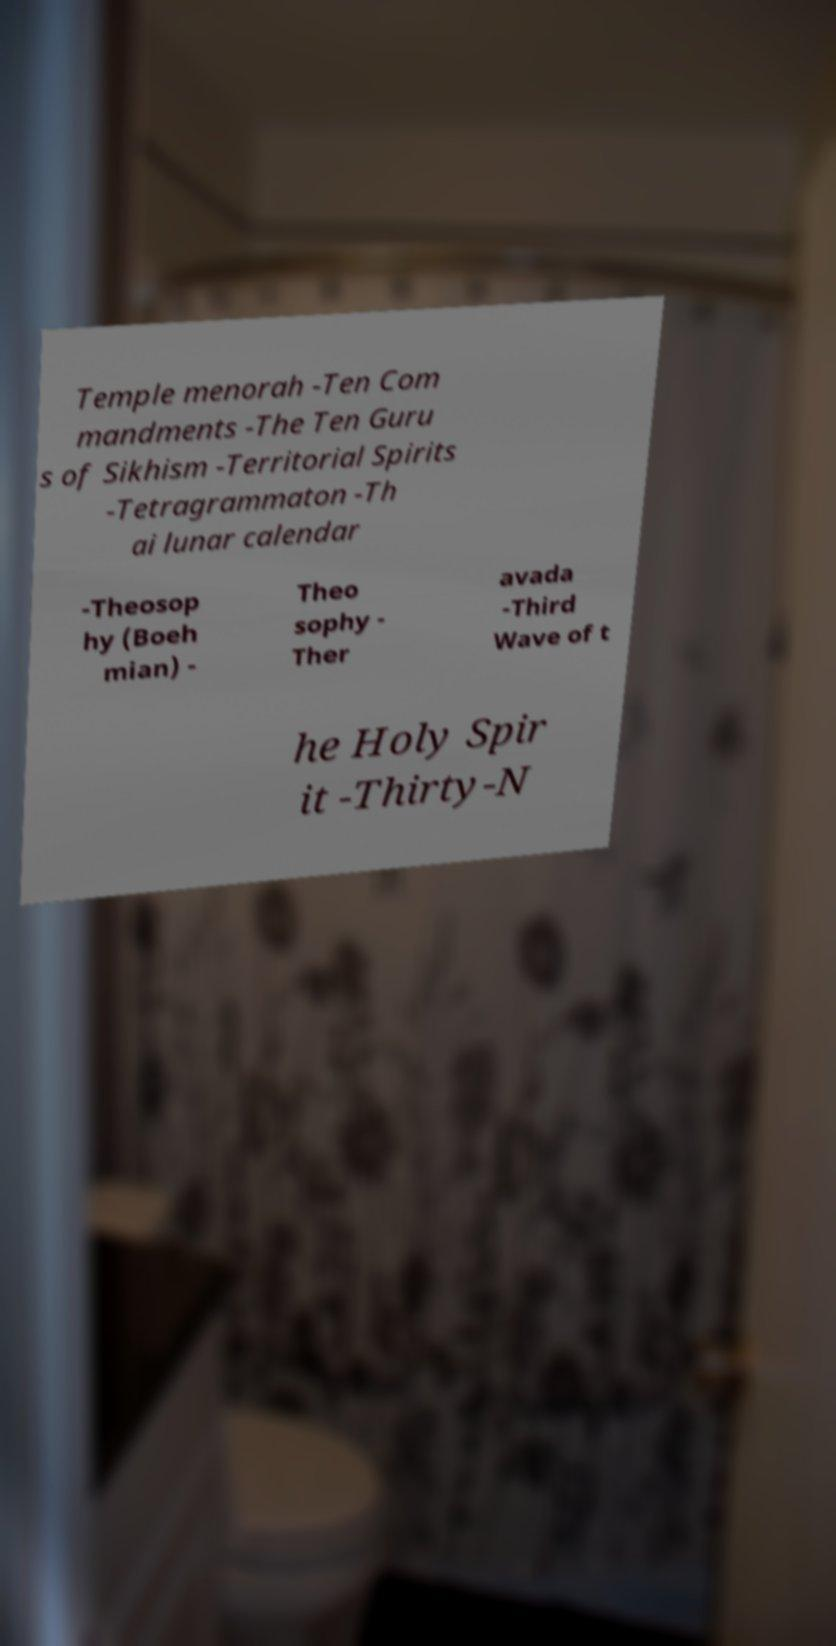Can you read and provide the text displayed in the image?This photo seems to have some interesting text. Can you extract and type it out for me? Temple menorah -Ten Com mandments -The Ten Guru s of Sikhism -Territorial Spirits -Tetragrammaton -Th ai lunar calendar -Theosop hy (Boeh mian) - Theo sophy - Ther avada -Third Wave of t he Holy Spir it -Thirty-N 